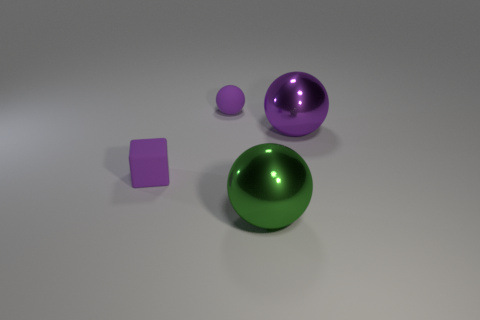Subtract all cyan cubes. How many purple spheres are left? 2 Subtract all purple spheres. How many spheres are left? 1 Add 4 big brown things. How many objects exist? 8 Subtract all red balls. Subtract all gray cylinders. How many balls are left? 3 Subtract all balls. How many objects are left? 1 Subtract 0 purple cylinders. How many objects are left? 4 Subtract all large gray metallic things. Subtract all large purple things. How many objects are left? 3 Add 3 green spheres. How many green spheres are left? 4 Add 2 metal spheres. How many metal spheres exist? 4 